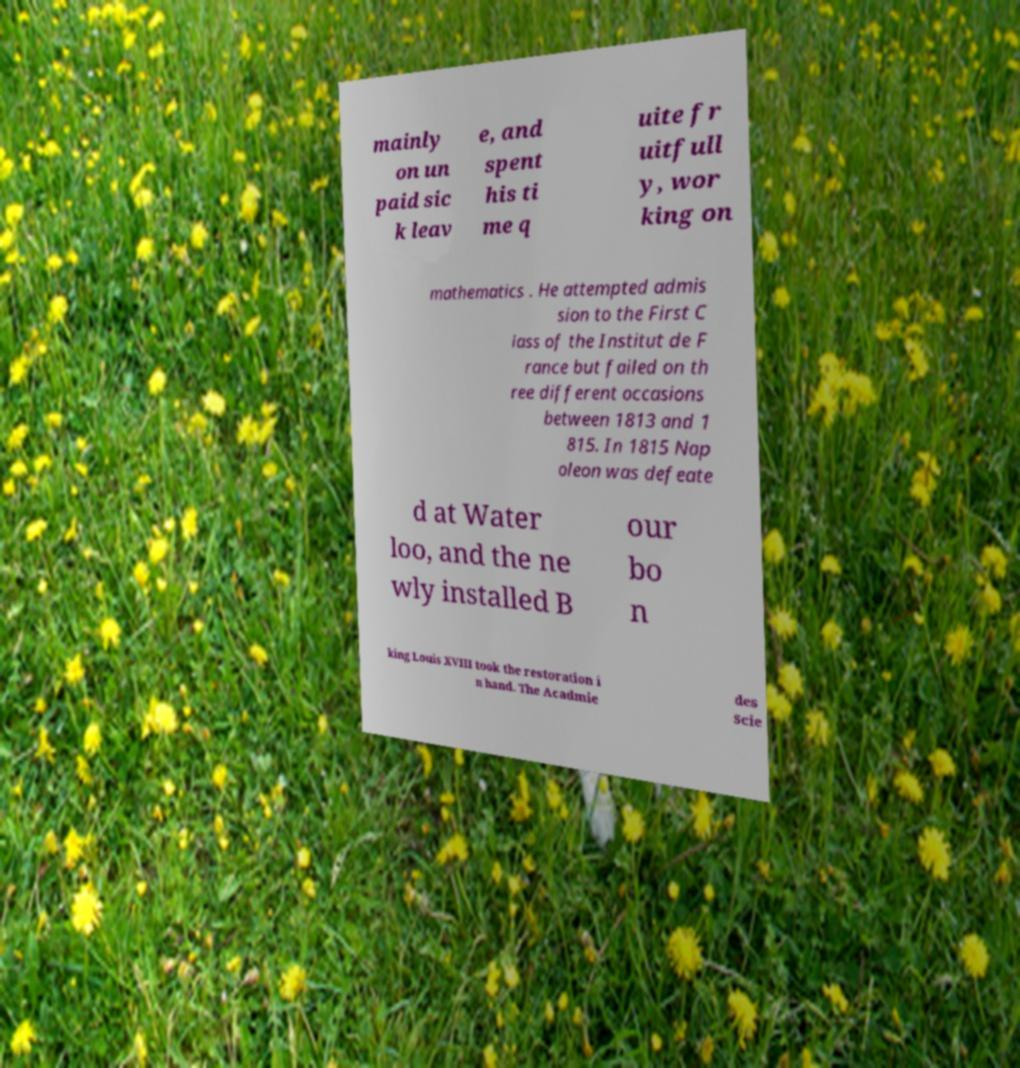Could you extract and type out the text from this image? mainly on un paid sic k leav e, and spent his ti me q uite fr uitfull y, wor king on mathematics . He attempted admis sion to the First C lass of the Institut de F rance but failed on th ree different occasions between 1813 and 1 815. In 1815 Nap oleon was defeate d at Water loo, and the ne wly installed B our bo n king Louis XVIII took the restoration i n hand. The Acadmie des Scie 